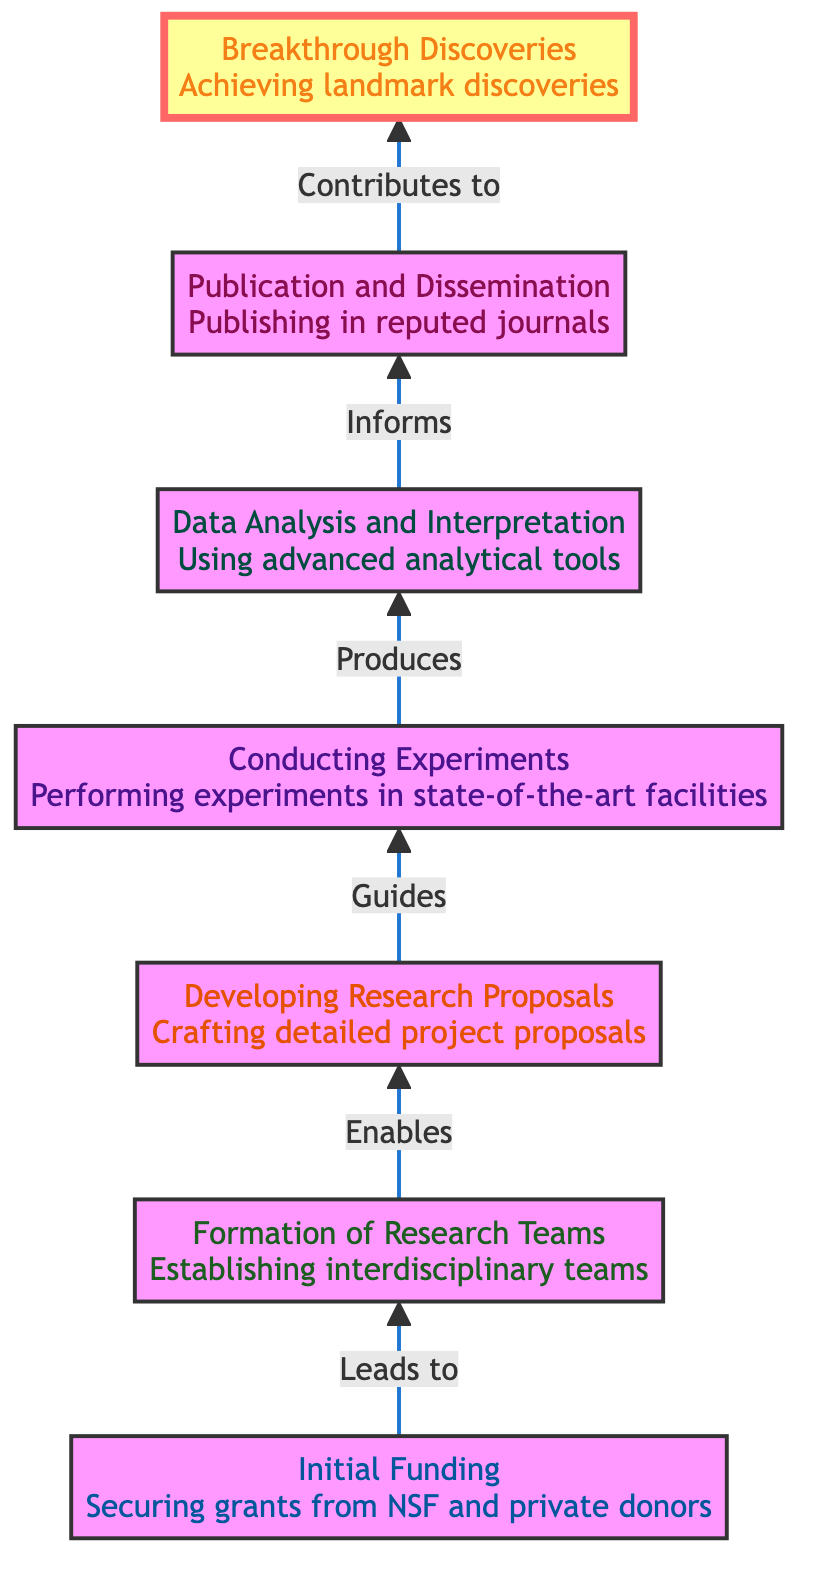What is the first stage in the diagram? The diagram starts from the bottom with the stage labeled "Initial Funding". This is the first node in the flowchart, so it is the first stage in the research contributions process.
Answer: Initial Funding How many stages are depicted in the diagram? The diagram outlines a total of seven stages from "Initial Funding" to "Breakthrough Discoveries". By counting each node in the flowchart, we arrive at the total number of stages.
Answer: Seven What does "Initial Funding" lead to? According to the diagram, "Initial Funding" leads to the next stage, which is "Formation of Research Teams". This connection signifies the flow of the research process from funding to team establishment.
Answer: Formation of Research Teams What is the final outcome represented in the diagram? The last node at the top of the diagram is "Breakthrough Discoveries," indicating that this is the ultimate goal or result of the entire research process as shown in the flowchart.
Answer: Breakthrough Discoveries What is the relationship between "Conducting Experiments" and "Data Analysis and Interpretation"? The diagram shows that "Conducting Experiments" produces results that directly inform the process of "Data Analysis and Interpretation". This indicates a flow of information from experiments to data analysis.
Answer: Produces Which stage includes the use of "advanced analytical tools"? The stage that involves the use of "advanced analytical tools" is "Data Analysis and Interpretation". This stage focuses on analyzing and interpreting experimental data, utilizing sophisticated software and techniques.
Answer: Data Analysis and Interpretation What type of teams are established during the "Formation of Research Teams" stage? The "Formation of Research Teams" stage emphasizes establishing interdisciplinary teams, which include faculty, undergraduate, and graduate students, critical for collaborative research efforts.
Answer: Interdisciplinary teams What do the published findings contribute to? The published findings, according to the diagram, contribute to the next step labeled "Breakthrough Discoveries". This shows that disseminating research results is integral to achieving innovative scientific outcomes.
Answer: Breakthrough Discoveries 